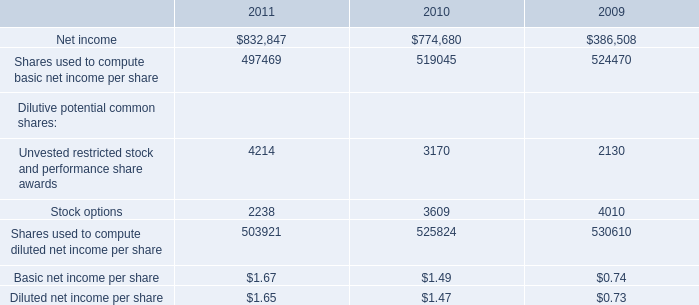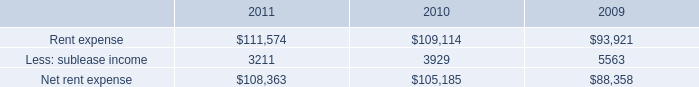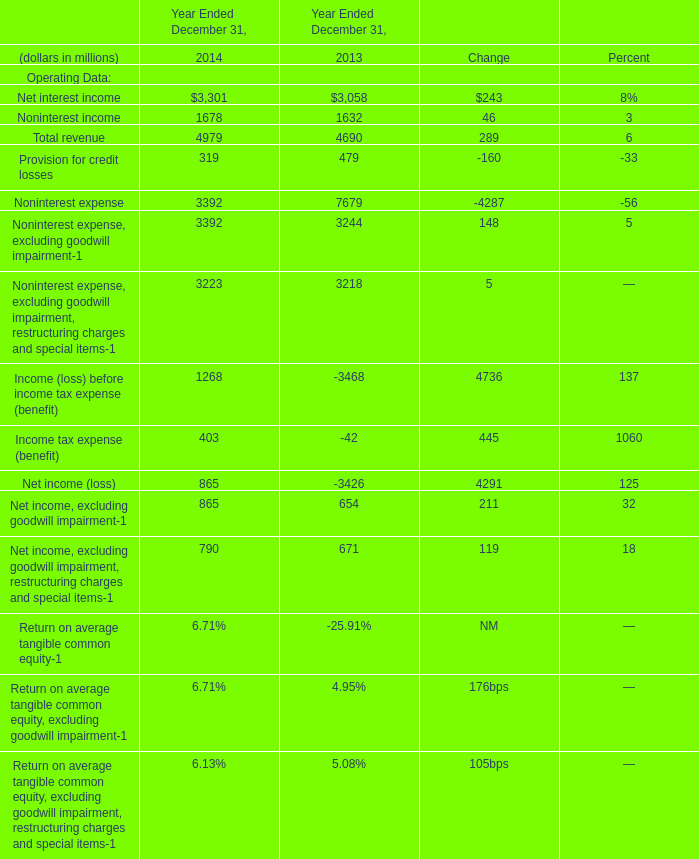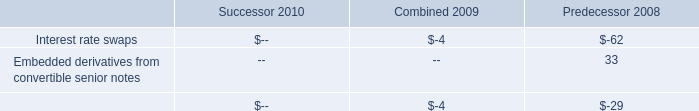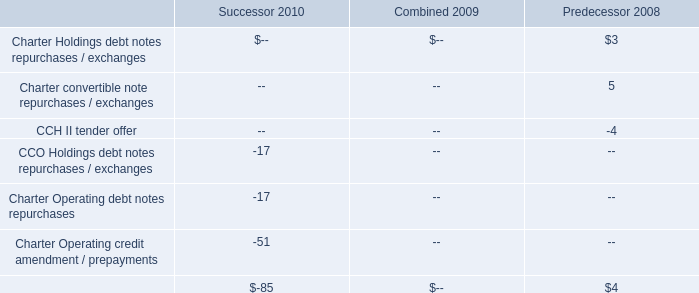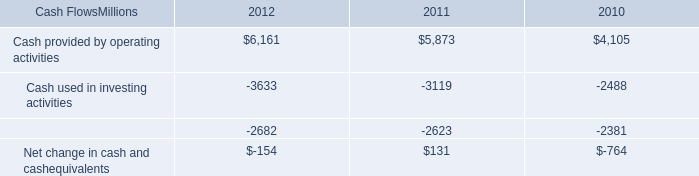What is the growing rate of Non interest expense in the year with the most Total revenue? 
Computations: ((3392 - 7679) / 3392)
Answer: -1.26386. 